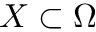<formula> <loc_0><loc_0><loc_500><loc_500>X \subset \Omega</formula> 